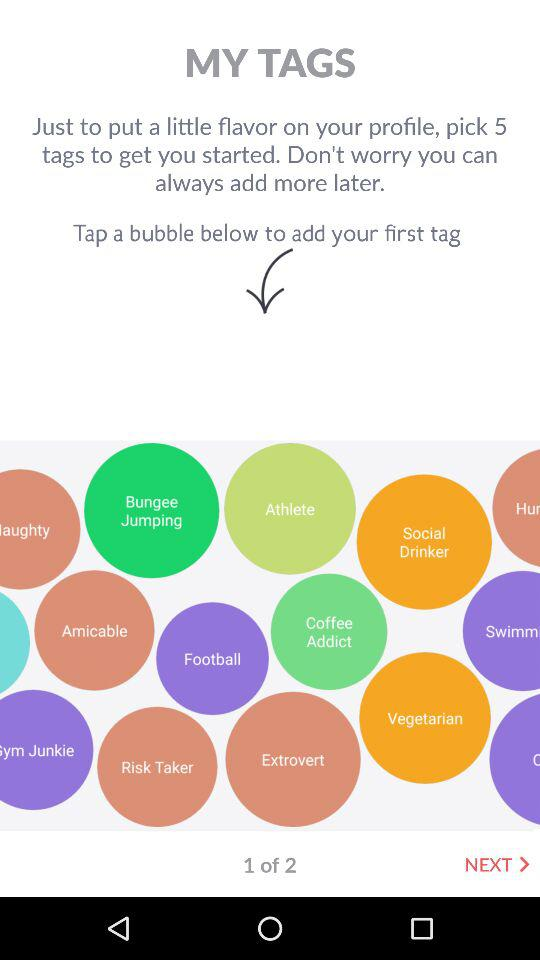How many tags can I add?
Answer the question using a single word or phrase. 5 